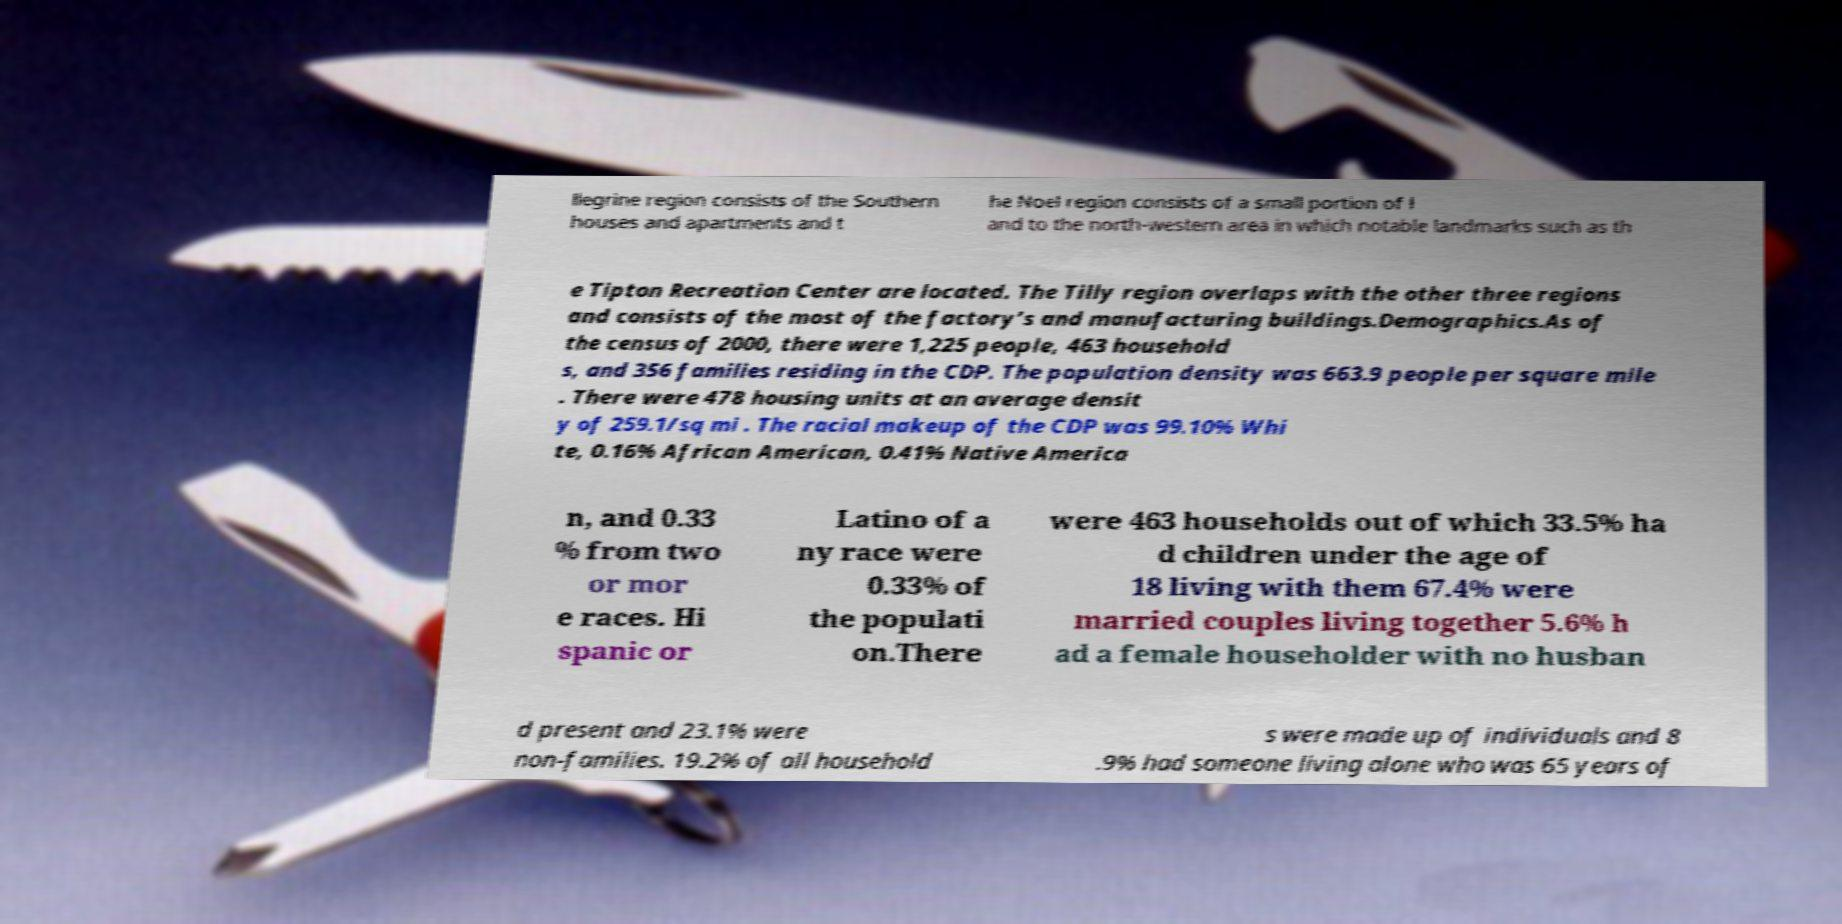Can you read and provide the text displayed in the image?This photo seems to have some interesting text. Can you extract and type it out for me? llegrine region consists of the Southern houses and apartments and t he Noel region consists of a small portion of l and to the north-western area in which notable landmarks such as th e Tipton Recreation Center are located. The Tilly region overlaps with the other three regions and consists of the most of the factory’s and manufacturing buildings.Demographics.As of the census of 2000, there were 1,225 people, 463 household s, and 356 families residing in the CDP. The population density was 663.9 people per square mile . There were 478 housing units at an average densit y of 259.1/sq mi . The racial makeup of the CDP was 99.10% Whi te, 0.16% African American, 0.41% Native America n, and 0.33 % from two or mor e races. Hi spanic or Latino of a ny race were 0.33% of the populati on.There were 463 households out of which 33.5% ha d children under the age of 18 living with them 67.4% were married couples living together 5.6% h ad a female householder with no husban d present and 23.1% were non-families. 19.2% of all household s were made up of individuals and 8 .9% had someone living alone who was 65 years of 